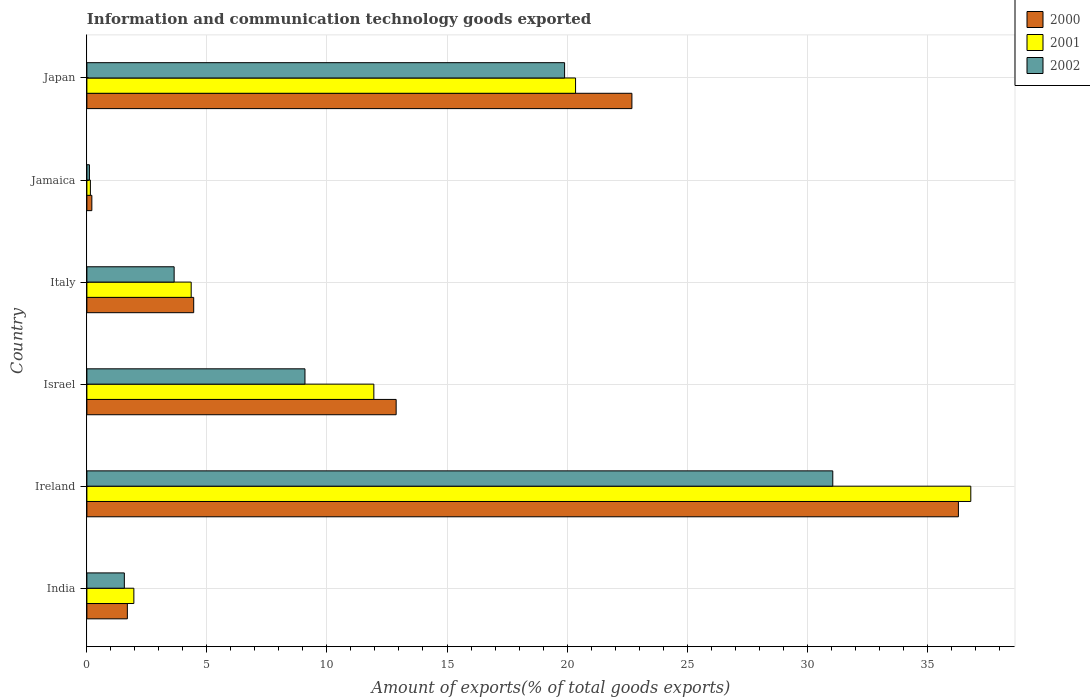How many groups of bars are there?
Give a very brief answer. 6. Are the number of bars on each tick of the Y-axis equal?
Give a very brief answer. Yes. How many bars are there on the 2nd tick from the top?
Your answer should be compact. 3. How many bars are there on the 4th tick from the bottom?
Your answer should be compact. 3. What is the label of the 5th group of bars from the top?
Provide a succinct answer. Ireland. What is the amount of goods exported in 2000 in Italy?
Make the answer very short. 4.45. Across all countries, what is the maximum amount of goods exported in 2002?
Offer a very short reply. 31.07. Across all countries, what is the minimum amount of goods exported in 2000?
Keep it short and to the point. 0.21. In which country was the amount of goods exported in 2002 maximum?
Make the answer very short. Ireland. In which country was the amount of goods exported in 2002 minimum?
Your answer should be compact. Jamaica. What is the total amount of goods exported in 2000 in the graph?
Offer a terse response. 78.23. What is the difference between the amount of goods exported in 2001 in Ireland and that in Israel?
Ensure brevity in your answer.  24.87. What is the difference between the amount of goods exported in 2002 in Israel and the amount of goods exported in 2000 in Jamaica?
Your response must be concise. 8.88. What is the average amount of goods exported in 2000 per country?
Give a very brief answer. 13.04. What is the difference between the amount of goods exported in 2002 and amount of goods exported in 2001 in Israel?
Make the answer very short. -2.87. What is the ratio of the amount of goods exported in 2002 in Israel to that in Jamaica?
Provide a short and direct response. 86.18. Is the difference between the amount of goods exported in 2002 in Ireland and Japan greater than the difference between the amount of goods exported in 2001 in Ireland and Japan?
Give a very brief answer. No. What is the difference between the highest and the second highest amount of goods exported in 2002?
Ensure brevity in your answer.  11.17. What is the difference between the highest and the lowest amount of goods exported in 2000?
Give a very brief answer. 36.1. Is the sum of the amount of goods exported in 2000 in Ireland and Jamaica greater than the maximum amount of goods exported in 2002 across all countries?
Offer a terse response. Yes. What does the 2nd bar from the bottom in India represents?
Offer a terse response. 2001. Is it the case that in every country, the sum of the amount of goods exported in 2002 and amount of goods exported in 2000 is greater than the amount of goods exported in 2001?
Give a very brief answer. Yes. How many bars are there?
Offer a very short reply. 18. Are all the bars in the graph horizontal?
Offer a terse response. Yes. How many countries are there in the graph?
Offer a very short reply. 6. What is the difference between two consecutive major ticks on the X-axis?
Keep it short and to the point. 5. Are the values on the major ticks of X-axis written in scientific E-notation?
Offer a very short reply. No. Does the graph contain grids?
Offer a terse response. Yes. What is the title of the graph?
Your answer should be very brief. Information and communication technology goods exported. What is the label or title of the X-axis?
Offer a very short reply. Amount of exports(% of total goods exports). What is the Amount of exports(% of total goods exports) in 2000 in India?
Keep it short and to the point. 1.69. What is the Amount of exports(% of total goods exports) in 2001 in India?
Offer a very short reply. 1.96. What is the Amount of exports(% of total goods exports) of 2002 in India?
Offer a very short reply. 1.56. What is the Amount of exports(% of total goods exports) of 2000 in Ireland?
Provide a succinct answer. 36.3. What is the Amount of exports(% of total goods exports) in 2001 in Ireland?
Provide a succinct answer. 36.82. What is the Amount of exports(% of total goods exports) in 2002 in Ireland?
Offer a terse response. 31.07. What is the Amount of exports(% of total goods exports) in 2000 in Israel?
Ensure brevity in your answer.  12.88. What is the Amount of exports(% of total goods exports) in 2001 in Israel?
Offer a very short reply. 11.95. What is the Amount of exports(% of total goods exports) in 2002 in Israel?
Make the answer very short. 9.08. What is the Amount of exports(% of total goods exports) of 2000 in Italy?
Your response must be concise. 4.45. What is the Amount of exports(% of total goods exports) of 2001 in Italy?
Ensure brevity in your answer.  4.34. What is the Amount of exports(% of total goods exports) in 2002 in Italy?
Keep it short and to the point. 3.63. What is the Amount of exports(% of total goods exports) in 2000 in Jamaica?
Offer a very short reply. 0.21. What is the Amount of exports(% of total goods exports) in 2001 in Jamaica?
Ensure brevity in your answer.  0.15. What is the Amount of exports(% of total goods exports) of 2002 in Jamaica?
Keep it short and to the point. 0.11. What is the Amount of exports(% of total goods exports) in 2000 in Japan?
Your answer should be compact. 22.7. What is the Amount of exports(% of total goods exports) in 2001 in Japan?
Your answer should be compact. 20.36. What is the Amount of exports(% of total goods exports) of 2002 in Japan?
Your answer should be compact. 19.9. Across all countries, what is the maximum Amount of exports(% of total goods exports) of 2000?
Ensure brevity in your answer.  36.3. Across all countries, what is the maximum Amount of exports(% of total goods exports) of 2001?
Your answer should be very brief. 36.82. Across all countries, what is the maximum Amount of exports(% of total goods exports) in 2002?
Offer a terse response. 31.07. Across all countries, what is the minimum Amount of exports(% of total goods exports) of 2000?
Make the answer very short. 0.21. Across all countries, what is the minimum Amount of exports(% of total goods exports) of 2001?
Offer a very short reply. 0.15. Across all countries, what is the minimum Amount of exports(% of total goods exports) of 2002?
Give a very brief answer. 0.11. What is the total Amount of exports(% of total goods exports) of 2000 in the graph?
Offer a terse response. 78.23. What is the total Amount of exports(% of total goods exports) of 2001 in the graph?
Make the answer very short. 75.57. What is the total Amount of exports(% of total goods exports) in 2002 in the graph?
Ensure brevity in your answer.  65.35. What is the difference between the Amount of exports(% of total goods exports) of 2000 in India and that in Ireland?
Ensure brevity in your answer.  -34.62. What is the difference between the Amount of exports(% of total goods exports) of 2001 in India and that in Ireland?
Provide a succinct answer. -34.86. What is the difference between the Amount of exports(% of total goods exports) in 2002 in India and that in Ireland?
Give a very brief answer. -29.51. What is the difference between the Amount of exports(% of total goods exports) of 2000 in India and that in Israel?
Ensure brevity in your answer.  -11.2. What is the difference between the Amount of exports(% of total goods exports) in 2001 in India and that in Israel?
Offer a terse response. -10. What is the difference between the Amount of exports(% of total goods exports) of 2002 in India and that in Israel?
Keep it short and to the point. -7.52. What is the difference between the Amount of exports(% of total goods exports) in 2000 in India and that in Italy?
Give a very brief answer. -2.76. What is the difference between the Amount of exports(% of total goods exports) in 2001 in India and that in Italy?
Offer a terse response. -2.39. What is the difference between the Amount of exports(% of total goods exports) in 2002 in India and that in Italy?
Keep it short and to the point. -2.07. What is the difference between the Amount of exports(% of total goods exports) of 2000 in India and that in Jamaica?
Ensure brevity in your answer.  1.48. What is the difference between the Amount of exports(% of total goods exports) of 2001 in India and that in Jamaica?
Give a very brief answer. 1.81. What is the difference between the Amount of exports(% of total goods exports) of 2002 in India and that in Jamaica?
Provide a succinct answer. 1.45. What is the difference between the Amount of exports(% of total goods exports) of 2000 in India and that in Japan?
Your answer should be compact. -21.02. What is the difference between the Amount of exports(% of total goods exports) in 2001 in India and that in Japan?
Your response must be concise. -18.4. What is the difference between the Amount of exports(% of total goods exports) in 2002 in India and that in Japan?
Your answer should be very brief. -18.34. What is the difference between the Amount of exports(% of total goods exports) in 2000 in Ireland and that in Israel?
Provide a succinct answer. 23.42. What is the difference between the Amount of exports(% of total goods exports) in 2001 in Ireland and that in Israel?
Your response must be concise. 24.87. What is the difference between the Amount of exports(% of total goods exports) in 2002 in Ireland and that in Israel?
Offer a terse response. 21.99. What is the difference between the Amount of exports(% of total goods exports) in 2000 in Ireland and that in Italy?
Your answer should be very brief. 31.85. What is the difference between the Amount of exports(% of total goods exports) in 2001 in Ireland and that in Italy?
Ensure brevity in your answer.  32.47. What is the difference between the Amount of exports(% of total goods exports) of 2002 in Ireland and that in Italy?
Make the answer very short. 27.44. What is the difference between the Amount of exports(% of total goods exports) in 2000 in Ireland and that in Jamaica?
Your response must be concise. 36.1. What is the difference between the Amount of exports(% of total goods exports) in 2001 in Ireland and that in Jamaica?
Your answer should be very brief. 36.67. What is the difference between the Amount of exports(% of total goods exports) in 2002 in Ireland and that in Jamaica?
Give a very brief answer. 30.96. What is the difference between the Amount of exports(% of total goods exports) in 2000 in Ireland and that in Japan?
Provide a succinct answer. 13.6. What is the difference between the Amount of exports(% of total goods exports) of 2001 in Ireland and that in Japan?
Provide a short and direct response. 16.46. What is the difference between the Amount of exports(% of total goods exports) of 2002 in Ireland and that in Japan?
Your response must be concise. 11.17. What is the difference between the Amount of exports(% of total goods exports) in 2000 in Israel and that in Italy?
Offer a terse response. 8.43. What is the difference between the Amount of exports(% of total goods exports) in 2001 in Israel and that in Italy?
Make the answer very short. 7.61. What is the difference between the Amount of exports(% of total goods exports) of 2002 in Israel and that in Italy?
Your answer should be very brief. 5.45. What is the difference between the Amount of exports(% of total goods exports) of 2000 in Israel and that in Jamaica?
Ensure brevity in your answer.  12.68. What is the difference between the Amount of exports(% of total goods exports) in 2001 in Israel and that in Jamaica?
Provide a succinct answer. 11.81. What is the difference between the Amount of exports(% of total goods exports) in 2002 in Israel and that in Jamaica?
Make the answer very short. 8.98. What is the difference between the Amount of exports(% of total goods exports) of 2000 in Israel and that in Japan?
Provide a short and direct response. -9.82. What is the difference between the Amount of exports(% of total goods exports) in 2001 in Israel and that in Japan?
Your answer should be very brief. -8.4. What is the difference between the Amount of exports(% of total goods exports) of 2002 in Israel and that in Japan?
Offer a terse response. -10.81. What is the difference between the Amount of exports(% of total goods exports) of 2000 in Italy and that in Jamaica?
Provide a succinct answer. 4.24. What is the difference between the Amount of exports(% of total goods exports) in 2001 in Italy and that in Jamaica?
Offer a very short reply. 4.2. What is the difference between the Amount of exports(% of total goods exports) of 2002 in Italy and that in Jamaica?
Your answer should be compact. 3.53. What is the difference between the Amount of exports(% of total goods exports) of 2000 in Italy and that in Japan?
Provide a short and direct response. -18.25. What is the difference between the Amount of exports(% of total goods exports) in 2001 in Italy and that in Japan?
Keep it short and to the point. -16.01. What is the difference between the Amount of exports(% of total goods exports) in 2002 in Italy and that in Japan?
Offer a terse response. -16.26. What is the difference between the Amount of exports(% of total goods exports) of 2000 in Jamaica and that in Japan?
Offer a terse response. -22.5. What is the difference between the Amount of exports(% of total goods exports) of 2001 in Jamaica and that in Japan?
Your answer should be very brief. -20.21. What is the difference between the Amount of exports(% of total goods exports) of 2002 in Jamaica and that in Japan?
Offer a terse response. -19.79. What is the difference between the Amount of exports(% of total goods exports) in 2000 in India and the Amount of exports(% of total goods exports) in 2001 in Ireland?
Your answer should be very brief. -35.13. What is the difference between the Amount of exports(% of total goods exports) in 2000 in India and the Amount of exports(% of total goods exports) in 2002 in Ireland?
Offer a terse response. -29.38. What is the difference between the Amount of exports(% of total goods exports) in 2001 in India and the Amount of exports(% of total goods exports) in 2002 in Ireland?
Offer a very short reply. -29.11. What is the difference between the Amount of exports(% of total goods exports) in 2000 in India and the Amount of exports(% of total goods exports) in 2001 in Israel?
Ensure brevity in your answer.  -10.27. What is the difference between the Amount of exports(% of total goods exports) in 2000 in India and the Amount of exports(% of total goods exports) in 2002 in Israel?
Ensure brevity in your answer.  -7.4. What is the difference between the Amount of exports(% of total goods exports) of 2001 in India and the Amount of exports(% of total goods exports) of 2002 in Israel?
Offer a very short reply. -7.13. What is the difference between the Amount of exports(% of total goods exports) in 2000 in India and the Amount of exports(% of total goods exports) in 2001 in Italy?
Provide a succinct answer. -2.66. What is the difference between the Amount of exports(% of total goods exports) in 2000 in India and the Amount of exports(% of total goods exports) in 2002 in Italy?
Keep it short and to the point. -1.95. What is the difference between the Amount of exports(% of total goods exports) in 2001 in India and the Amount of exports(% of total goods exports) in 2002 in Italy?
Your answer should be compact. -1.68. What is the difference between the Amount of exports(% of total goods exports) in 2000 in India and the Amount of exports(% of total goods exports) in 2001 in Jamaica?
Ensure brevity in your answer.  1.54. What is the difference between the Amount of exports(% of total goods exports) in 2000 in India and the Amount of exports(% of total goods exports) in 2002 in Jamaica?
Give a very brief answer. 1.58. What is the difference between the Amount of exports(% of total goods exports) of 2001 in India and the Amount of exports(% of total goods exports) of 2002 in Jamaica?
Make the answer very short. 1.85. What is the difference between the Amount of exports(% of total goods exports) of 2000 in India and the Amount of exports(% of total goods exports) of 2001 in Japan?
Provide a short and direct response. -18.67. What is the difference between the Amount of exports(% of total goods exports) in 2000 in India and the Amount of exports(% of total goods exports) in 2002 in Japan?
Provide a succinct answer. -18.21. What is the difference between the Amount of exports(% of total goods exports) of 2001 in India and the Amount of exports(% of total goods exports) of 2002 in Japan?
Your answer should be compact. -17.94. What is the difference between the Amount of exports(% of total goods exports) in 2000 in Ireland and the Amount of exports(% of total goods exports) in 2001 in Israel?
Your answer should be very brief. 24.35. What is the difference between the Amount of exports(% of total goods exports) in 2000 in Ireland and the Amount of exports(% of total goods exports) in 2002 in Israel?
Your answer should be very brief. 27.22. What is the difference between the Amount of exports(% of total goods exports) in 2001 in Ireland and the Amount of exports(% of total goods exports) in 2002 in Israel?
Your response must be concise. 27.73. What is the difference between the Amount of exports(% of total goods exports) of 2000 in Ireland and the Amount of exports(% of total goods exports) of 2001 in Italy?
Keep it short and to the point. 31.96. What is the difference between the Amount of exports(% of total goods exports) of 2000 in Ireland and the Amount of exports(% of total goods exports) of 2002 in Italy?
Offer a very short reply. 32.67. What is the difference between the Amount of exports(% of total goods exports) of 2001 in Ireland and the Amount of exports(% of total goods exports) of 2002 in Italy?
Offer a terse response. 33.18. What is the difference between the Amount of exports(% of total goods exports) of 2000 in Ireland and the Amount of exports(% of total goods exports) of 2001 in Jamaica?
Ensure brevity in your answer.  36.16. What is the difference between the Amount of exports(% of total goods exports) in 2000 in Ireland and the Amount of exports(% of total goods exports) in 2002 in Jamaica?
Offer a very short reply. 36.2. What is the difference between the Amount of exports(% of total goods exports) in 2001 in Ireland and the Amount of exports(% of total goods exports) in 2002 in Jamaica?
Offer a very short reply. 36.71. What is the difference between the Amount of exports(% of total goods exports) in 2000 in Ireland and the Amount of exports(% of total goods exports) in 2001 in Japan?
Give a very brief answer. 15.95. What is the difference between the Amount of exports(% of total goods exports) in 2000 in Ireland and the Amount of exports(% of total goods exports) in 2002 in Japan?
Offer a very short reply. 16.4. What is the difference between the Amount of exports(% of total goods exports) in 2001 in Ireland and the Amount of exports(% of total goods exports) in 2002 in Japan?
Ensure brevity in your answer.  16.92. What is the difference between the Amount of exports(% of total goods exports) of 2000 in Israel and the Amount of exports(% of total goods exports) of 2001 in Italy?
Keep it short and to the point. 8.54. What is the difference between the Amount of exports(% of total goods exports) of 2000 in Israel and the Amount of exports(% of total goods exports) of 2002 in Italy?
Keep it short and to the point. 9.25. What is the difference between the Amount of exports(% of total goods exports) in 2001 in Israel and the Amount of exports(% of total goods exports) in 2002 in Italy?
Give a very brief answer. 8.32. What is the difference between the Amount of exports(% of total goods exports) of 2000 in Israel and the Amount of exports(% of total goods exports) of 2001 in Jamaica?
Offer a terse response. 12.74. What is the difference between the Amount of exports(% of total goods exports) in 2000 in Israel and the Amount of exports(% of total goods exports) in 2002 in Jamaica?
Provide a short and direct response. 12.78. What is the difference between the Amount of exports(% of total goods exports) of 2001 in Israel and the Amount of exports(% of total goods exports) of 2002 in Jamaica?
Give a very brief answer. 11.85. What is the difference between the Amount of exports(% of total goods exports) in 2000 in Israel and the Amount of exports(% of total goods exports) in 2001 in Japan?
Your response must be concise. -7.47. What is the difference between the Amount of exports(% of total goods exports) of 2000 in Israel and the Amount of exports(% of total goods exports) of 2002 in Japan?
Provide a short and direct response. -7.02. What is the difference between the Amount of exports(% of total goods exports) of 2001 in Israel and the Amount of exports(% of total goods exports) of 2002 in Japan?
Ensure brevity in your answer.  -7.95. What is the difference between the Amount of exports(% of total goods exports) of 2000 in Italy and the Amount of exports(% of total goods exports) of 2001 in Jamaica?
Give a very brief answer. 4.3. What is the difference between the Amount of exports(% of total goods exports) of 2000 in Italy and the Amount of exports(% of total goods exports) of 2002 in Jamaica?
Provide a succinct answer. 4.34. What is the difference between the Amount of exports(% of total goods exports) in 2001 in Italy and the Amount of exports(% of total goods exports) in 2002 in Jamaica?
Give a very brief answer. 4.24. What is the difference between the Amount of exports(% of total goods exports) in 2000 in Italy and the Amount of exports(% of total goods exports) in 2001 in Japan?
Provide a short and direct response. -15.91. What is the difference between the Amount of exports(% of total goods exports) of 2000 in Italy and the Amount of exports(% of total goods exports) of 2002 in Japan?
Provide a short and direct response. -15.45. What is the difference between the Amount of exports(% of total goods exports) of 2001 in Italy and the Amount of exports(% of total goods exports) of 2002 in Japan?
Offer a terse response. -15.55. What is the difference between the Amount of exports(% of total goods exports) of 2000 in Jamaica and the Amount of exports(% of total goods exports) of 2001 in Japan?
Offer a very short reply. -20.15. What is the difference between the Amount of exports(% of total goods exports) of 2000 in Jamaica and the Amount of exports(% of total goods exports) of 2002 in Japan?
Your answer should be compact. -19.69. What is the difference between the Amount of exports(% of total goods exports) of 2001 in Jamaica and the Amount of exports(% of total goods exports) of 2002 in Japan?
Keep it short and to the point. -19.75. What is the average Amount of exports(% of total goods exports) in 2000 per country?
Offer a very short reply. 13.04. What is the average Amount of exports(% of total goods exports) in 2001 per country?
Provide a short and direct response. 12.6. What is the average Amount of exports(% of total goods exports) of 2002 per country?
Your answer should be very brief. 10.89. What is the difference between the Amount of exports(% of total goods exports) in 2000 and Amount of exports(% of total goods exports) in 2001 in India?
Provide a succinct answer. -0.27. What is the difference between the Amount of exports(% of total goods exports) of 2000 and Amount of exports(% of total goods exports) of 2002 in India?
Offer a terse response. 0.13. What is the difference between the Amount of exports(% of total goods exports) of 2001 and Amount of exports(% of total goods exports) of 2002 in India?
Keep it short and to the point. 0.4. What is the difference between the Amount of exports(% of total goods exports) of 2000 and Amount of exports(% of total goods exports) of 2001 in Ireland?
Make the answer very short. -0.52. What is the difference between the Amount of exports(% of total goods exports) in 2000 and Amount of exports(% of total goods exports) in 2002 in Ireland?
Make the answer very short. 5.23. What is the difference between the Amount of exports(% of total goods exports) of 2001 and Amount of exports(% of total goods exports) of 2002 in Ireland?
Keep it short and to the point. 5.75. What is the difference between the Amount of exports(% of total goods exports) of 2000 and Amount of exports(% of total goods exports) of 2001 in Israel?
Ensure brevity in your answer.  0.93. What is the difference between the Amount of exports(% of total goods exports) of 2000 and Amount of exports(% of total goods exports) of 2002 in Israel?
Your answer should be compact. 3.8. What is the difference between the Amount of exports(% of total goods exports) in 2001 and Amount of exports(% of total goods exports) in 2002 in Israel?
Your response must be concise. 2.87. What is the difference between the Amount of exports(% of total goods exports) in 2000 and Amount of exports(% of total goods exports) in 2001 in Italy?
Ensure brevity in your answer.  0.1. What is the difference between the Amount of exports(% of total goods exports) in 2000 and Amount of exports(% of total goods exports) in 2002 in Italy?
Make the answer very short. 0.81. What is the difference between the Amount of exports(% of total goods exports) of 2001 and Amount of exports(% of total goods exports) of 2002 in Italy?
Ensure brevity in your answer.  0.71. What is the difference between the Amount of exports(% of total goods exports) of 2000 and Amount of exports(% of total goods exports) of 2001 in Jamaica?
Offer a terse response. 0.06. What is the difference between the Amount of exports(% of total goods exports) in 2000 and Amount of exports(% of total goods exports) in 2002 in Jamaica?
Keep it short and to the point. 0.1. What is the difference between the Amount of exports(% of total goods exports) of 2001 and Amount of exports(% of total goods exports) of 2002 in Jamaica?
Ensure brevity in your answer.  0.04. What is the difference between the Amount of exports(% of total goods exports) of 2000 and Amount of exports(% of total goods exports) of 2001 in Japan?
Make the answer very short. 2.35. What is the difference between the Amount of exports(% of total goods exports) of 2000 and Amount of exports(% of total goods exports) of 2002 in Japan?
Offer a terse response. 2.8. What is the difference between the Amount of exports(% of total goods exports) of 2001 and Amount of exports(% of total goods exports) of 2002 in Japan?
Offer a very short reply. 0.46. What is the ratio of the Amount of exports(% of total goods exports) of 2000 in India to that in Ireland?
Give a very brief answer. 0.05. What is the ratio of the Amount of exports(% of total goods exports) of 2001 in India to that in Ireland?
Provide a short and direct response. 0.05. What is the ratio of the Amount of exports(% of total goods exports) of 2002 in India to that in Ireland?
Keep it short and to the point. 0.05. What is the ratio of the Amount of exports(% of total goods exports) in 2000 in India to that in Israel?
Ensure brevity in your answer.  0.13. What is the ratio of the Amount of exports(% of total goods exports) in 2001 in India to that in Israel?
Your response must be concise. 0.16. What is the ratio of the Amount of exports(% of total goods exports) of 2002 in India to that in Israel?
Your answer should be very brief. 0.17. What is the ratio of the Amount of exports(% of total goods exports) of 2000 in India to that in Italy?
Your response must be concise. 0.38. What is the ratio of the Amount of exports(% of total goods exports) in 2001 in India to that in Italy?
Provide a short and direct response. 0.45. What is the ratio of the Amount of exports(% of total goods exports) in 2002 in India to that in Italy?
Offer a very short reply. 0.43. What is the ratio of the Amount of exports(% of total goods exports) in 2000 in India to that in Jamaica?
Provide a short and direct response. 8.17. What is the ratio of the Amount of exports(% of total goods exports) in 2001 in India to that in Jamaica?
Make the answer very short. 13.44. What is the ratio of the Amount of exports(% of total goods exports) in 2002 in India to that in Jamaica?
Ensure brevity in your answer.  14.8. What is the ratio of the Amount of exports(% of total goods exports) of 2000 in India to that in Japan?
Provide a short and direct response. 0.07. What is the ratio of the Amount of exports(% of total goods exports) of 2001 in India to that in Japan?
Offer a terse response. 0.1. What is the ratio of the Amount of exports(% of total goods exports) of 2002 in India to that in Japan?
Provide a short and direct response. 0.08. What is the ratio of the Amount of exports(% of total goods exports) in 2000 in Ireland to that in Israel?
Ensure brevity in your answer.  2.82. What is the ratio of the Amount of exports(% of total goods exports) of 2001 in Ireland to that in Israel?
Keep it short and to the point. 3.08. What is the ratio of the Amount of exports(% of total goods exports) in 2002 in Ireland to that in Israel?
Keep it short and to the point. 3.42. What is the ratio of the Amount of exports(% of total goods exports) in 2000 in Ireland to that in Italy?
Offer a terse response. 8.16. What is the ratio of the Amount of exports(% of total goods exports) in 2001 in Ireland to that in Italy?
Your response must be concise. 8.47. What is the ratio of the Amount of exports(% of total goods exports) of 2002 in Ireland to that in Italy?
Your answer should be compact. 8.55. What is the ratio of the Amount of exports(% of total goods exports) of 2000 in Ireland to that in Jamaica?
Ensure brevity in your answer.  175.91. What is the ratio of the Amount of exports(% of total goods exports) in 2001 in Ireland to that in Jamaica?
Provide a short and direct response. 252.89. What is the ratio of the Amount of exports(% of total goods exports) in 2002 in Ireland to that in Jamaica?
Offer a terse response. 294.76. What is the ratio of the Amount of exports(% of total goods exports) in 2000 in Ireland to that in Japan?
Keep it short and to the point. 1.6. What is the ratio of the Amount of exports(% of total goods exports) of 2001 in Ireland to that in Japan?
Your answer should be compact. 1.81. What is the ratio of the Amount of exports(% of total goods exports) in 2002 in Ireland to that in Japan?
Keep it short and to the point. 1.56. What is the ratio of the Amount of exports(% of total goods exports) in 2000 in Israel to that in Italy?
Keep it short and to the point. 2.9. What is the ratio of the Amount of exports(% of total goods exports) of 2001 in Israel to that in Italy?
Provide a short and direct response. 2.75. What is the ratio of the Amount of exports(% of total goods exports) of 2002 in Israel to that in Italy?
Your response must be concise. 2.5. What is the ratio of the Amount of exports(% of total goods exports) in 2000 in Israel to that in Jamaica?
Your answer should be very brief. 62.42. What is the ratio of the Amount of exports(% of total goods exports) of 2001 in Israel to that in Jamaica?
Your answer should be compact. 82.1. What is the ratio of the Amount of exports(% of total goods exports) of 2002 in Israel to that in Jamaica?
Make the answer very short. 86.18. What is the ratio of the Amount of exports(% of total goods exports) of 2000 in Israel to that in Japan?
Your answer should be very brief. 0.57. What is the ratio of the Amount of exports(% of total goods exports) in 2001 in Israel to that in Japan?
Your response must be concise. 0.59. What is the ratio of the Amount of exports(% of total goods exports) of 2002 in Israel to that in Japan?
Provide a short and direct response. 0.46. What is the ratio of the Amount of exports(% of total goods exports) of 2000 in Italy to that in Jamaica?
Your answer should be compact. 21.56. What is the ratio of the Amount of exports(% of total goods exports) in 2001 in Italy to that in Jamaica?
Offer a very short reply. 29.84. What is the ratio of the Amount of exports(% of total goods exports) in 2002 in Italy to that in Jamaica?
Offer a very short reply. 34.48. What is the ratio of the Amount of exports(% of total goods exports) of 2000 in Italy to that in Japan?
Offer a terse response. 0.2. What is the ratio of the Amount of exports(% of total goods exports) in 2001 in Italy to that in Japan?
Keep it short and to the point. 0.21. What is the ratio of the Amount of exports(% of total goods exports) in 2002 in Italy to that in Japan?
Give a very brief answer. 0.18. What is the ratio of the Amount of exports(% of total goods exports) of 2000 in Jamaica to that in Japan?
Offer a very short reply. 0.01. What is the ratio of the Amount of exports(% of total goods exports) of 2001 in Jamaica to that in Japan?
Offer a terse response. 0.01. What is the ratio of the Amount of exports(% of total goods exports) in 2002 in Jamaica to that in Japan?
Keep it short and to the point. 0.01. What is the difference between the highest and the second highest Amount of exports(% of total goods exports) in 2000?
Your answer should be very brief. 13.6. What is the difference between the highest and the second highest Amount of exports(% of total goods exports) of 2001?
Offer a terse response. 16.46. What is the difference between the highest and the second highest Amount of exports(% of total goods exports) in 2002?
Provide a short and direct response. 11.17. What is the difference between the highest and the lowest Amount of exports(% of total goods exports) of 2000?
Your answer should be very brief. 36.1. What is the difference between the highest and the lowest Amount of exports(% of total goods exports) of 2001?
Keep it short and to the point. 36.67. What is the difference between the highest and the lowest Amount of exports(% of total goods exports) of 2002?
Your answer should be compact. 30.96. 